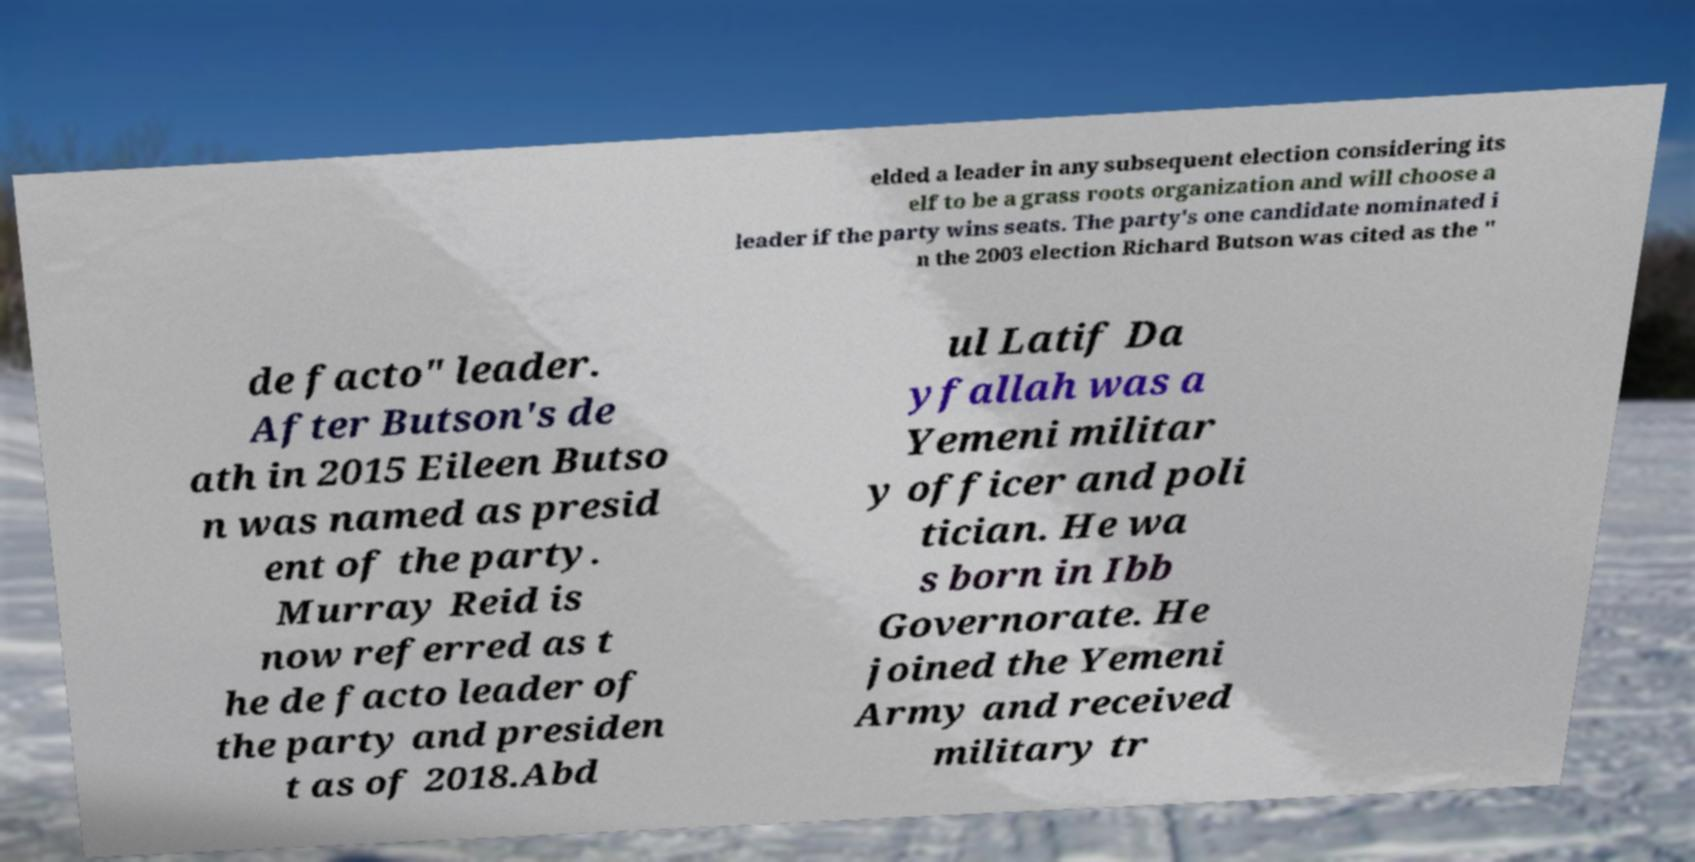Could you extract and type out the text from this image? elded a leader in any subsequent election considering its elf to be a grass roots organization and will choose a leader if the party wins seats. The party's one candidate nominated i n the 2003 election Richard Butson was cited as the " de facto" leader. After Butson's de ath in 2015 Eileen Butso n was named as presid ent of the party. Murray Reid is now referred as t he de facto leader of the party and presiden t as of 2018.Abd ul Latif Da yfallah was a Yemeni militar y officer and poli tician. He wa s born in Ibb Governorate. He joined the Yemeni Army and received military tr 